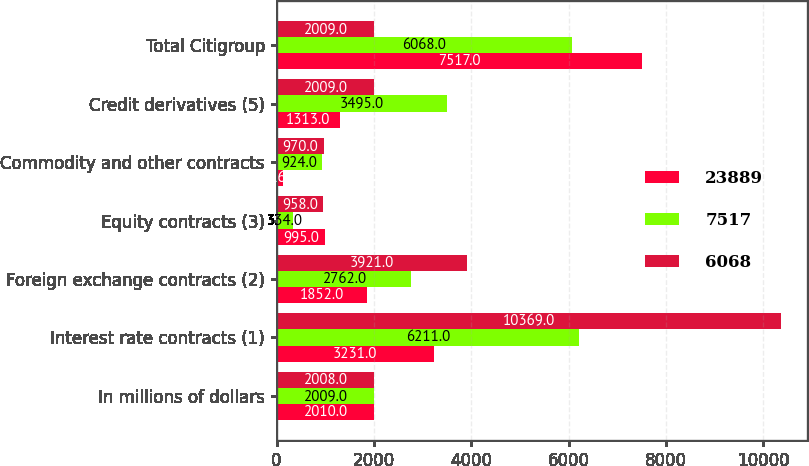Convert chart to OTSL. <chart><loc_0><loc_0><loc_500><loc_500><stacked_bar_chart><ecel><fcel>In millions of dollars<fcel>Interest rate contracts (1)<fcel>Foreign exchange contracts (2)<fcel>Equity contracts (3)<fcel>Commodity and other contracts<fcel>Credit derivatives (5)<fcel>Total Citigroup<nl><fcel>23889<fcel>2010<fcel>3231<fcel>1852<fcel>995<fcel>126<fcel>1313<fcel>7517<nl><fcel>7517<fcel>2009<fcel>6211<fcel>2762<fcel>334<fcel>924<fcel>3495<fcel>6068<nl><fcel>6068<fcel>2008<fcel>10369<fcel>3921<fcel>958<fcel>970<fcel>2009<fcel>2009<nl></chart> 